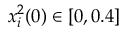Convert formula to latex. <formula><loc_0><loc_0><loc_500><loc_500>x _ { i } ^ { 2 } ( 0 ) \in [ 0 , 0 . 4 ]</formula> 